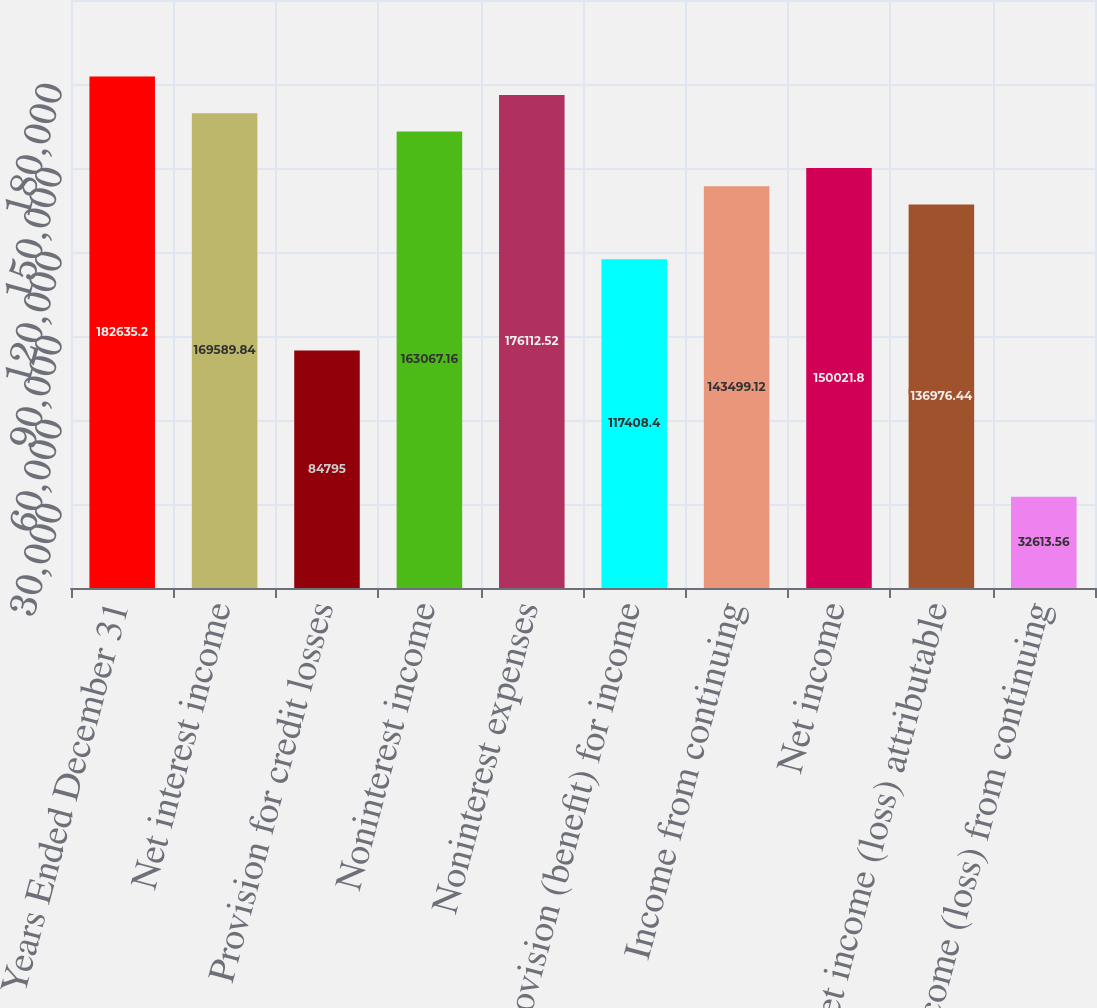Convert chart to OTSL. <chart><loc_0><loc_0><loc_500><loc_500><bar_chart><fcel>Years Ended December 31<fcel>Net interest income<fcel>Provision for credit losses<fcel>Noninterest income<fcel>Noninterest expenses<fcel>Provision (benefit) for income<fcel>Income from continuing<fcel>Net income<fcel>Net income (loss) attributable<fcel>Income (loss) from continuing<nl><fcel>182635<fcel>169590<fcel>84795<fcel>163067<fcel>176113<fcel>117408<fcel>143499<fcel>150022<fcel>136976<fcel>32613.6<nl></chart> 